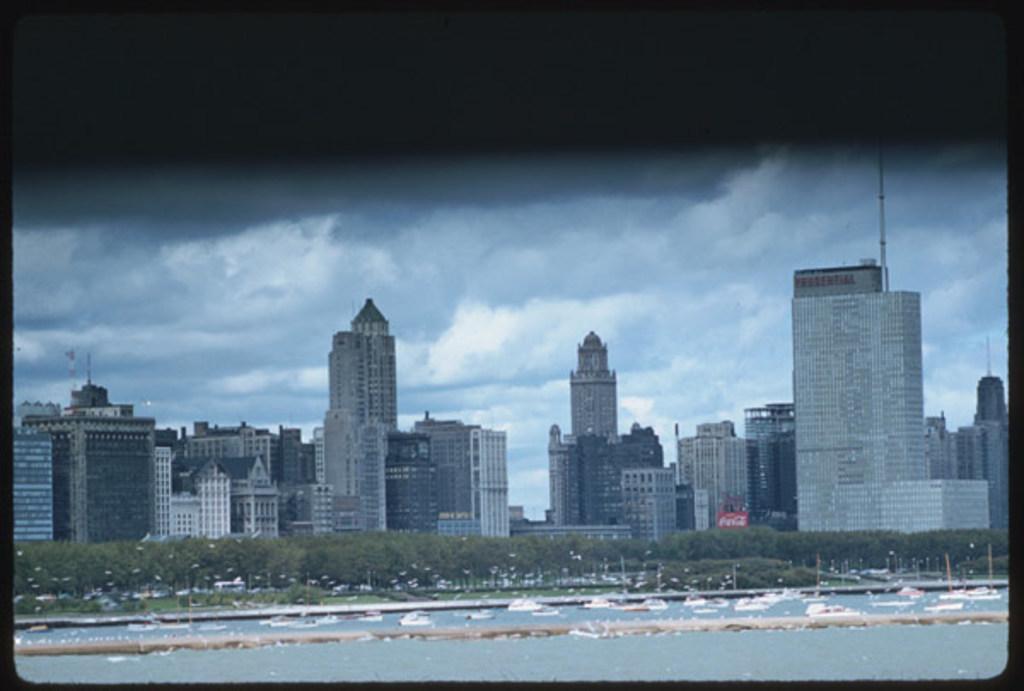How would you summarize this image in a sentence or two? In this image, we can see so many buildings, trees, poles, plants, vehicles, boats and water. Background we can see the cloudy sky. Top of the image, we can see black color. 